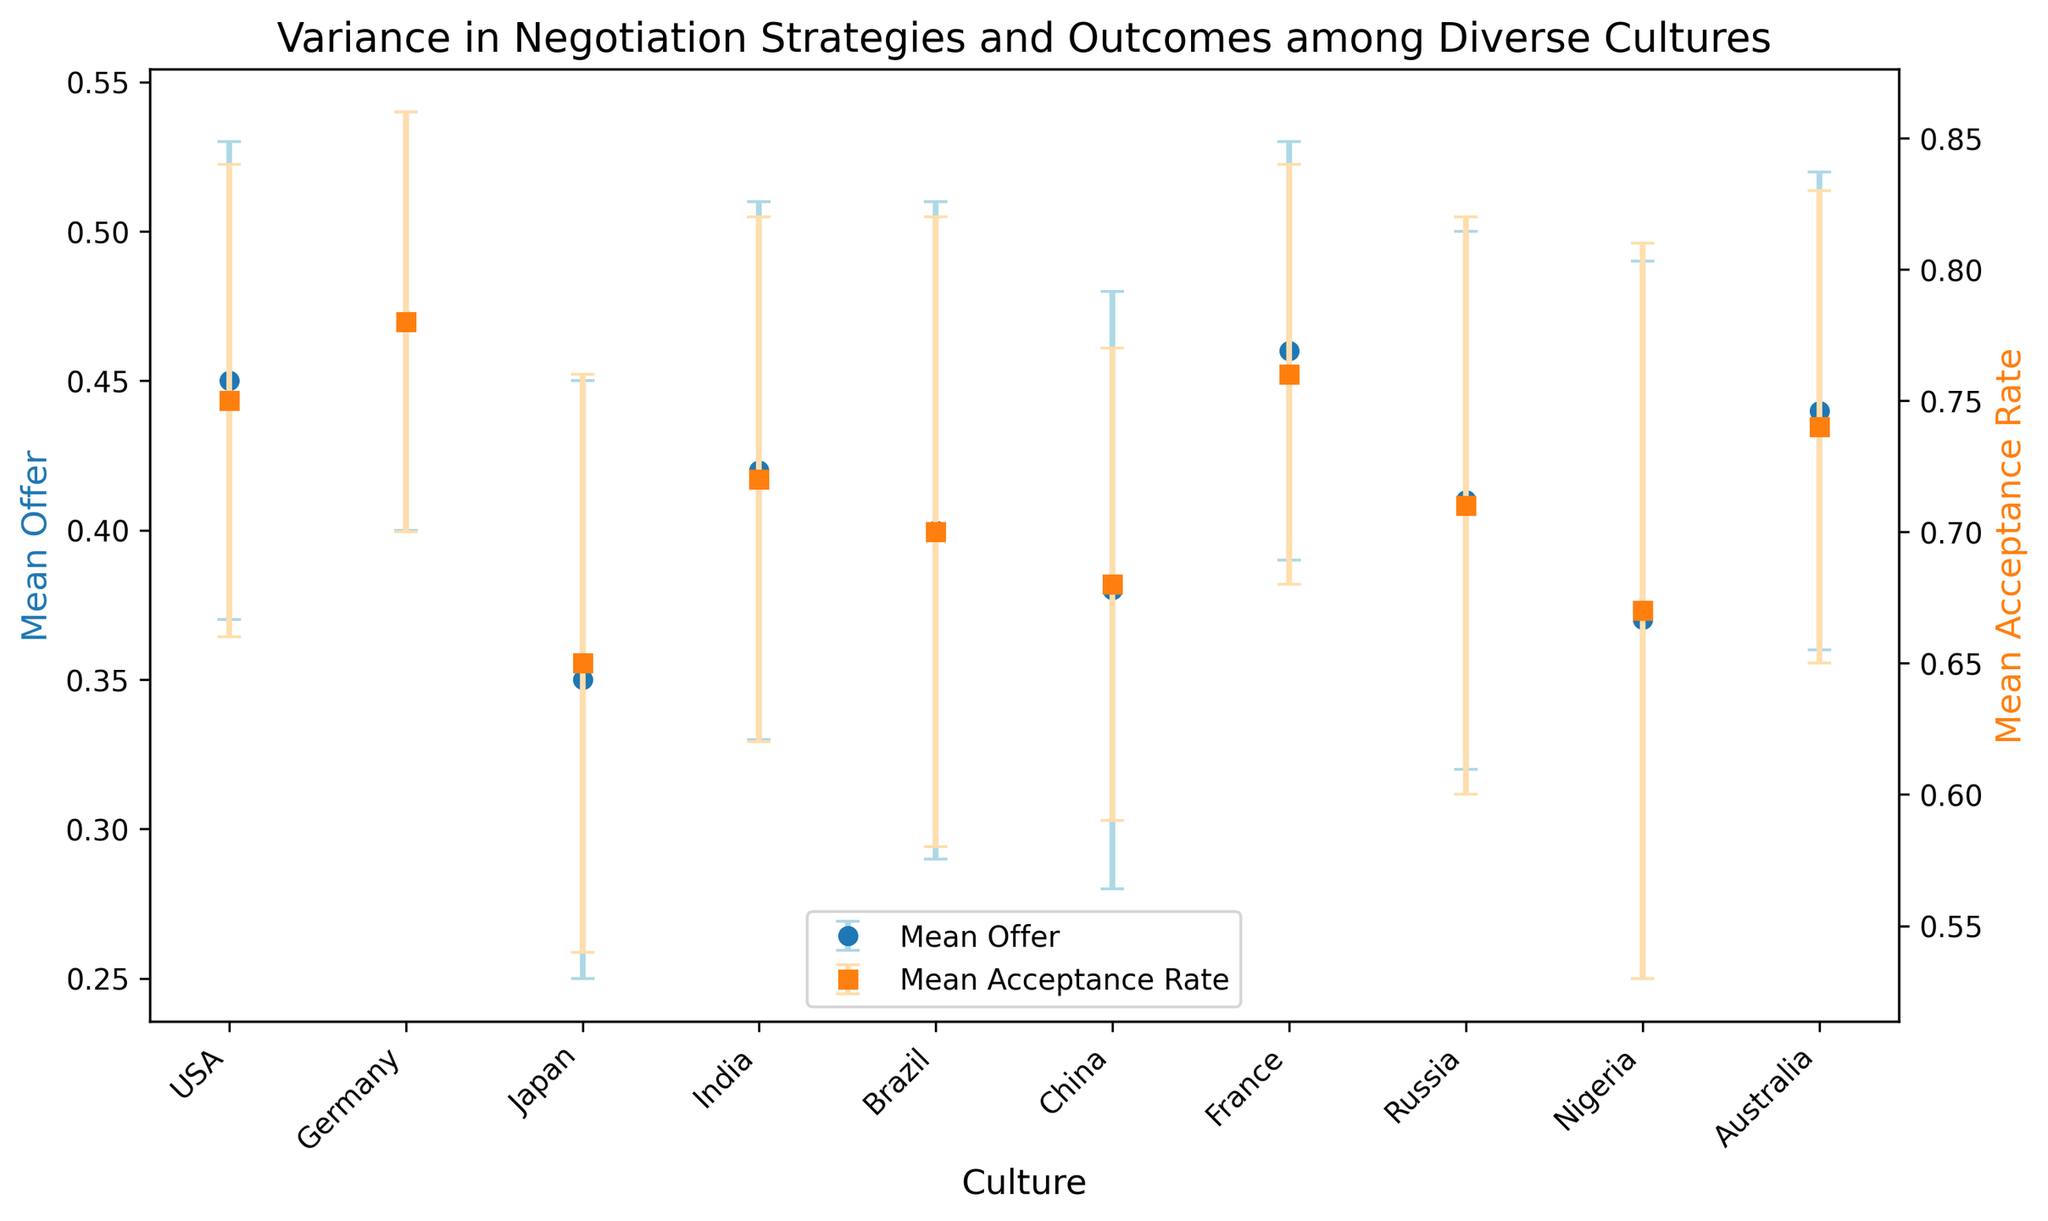Which culture has the highest mean offer? By examining the y-values of the blue dots (Mean Offer) on the left y-axis, Germany has the highest mean offer with a value of 0.47.
Answer: Germany Which culture has the lowest mean acceptance rate? By observing the y-values of the orange squares (Mean Acceptance Rate) on the right y-axis, Nigeria has the lowest mean acceptance rate with a value of 0.67.
Answer: Nigeria What is the difference in mean offer between USA and Japan? The mean offer for USA is 0.45 and for Japan, it is 0.35. The difference is 0.45 - 0.35 = 0.10.
Answer: 0.10 Which culture has the highest standard deviation in acceptance rate? By looking at the error bars for Mean Acceptance Rate (orange squares), Nigeria has the highest standard deviation in acceptance rate, which is 0.14.
Answer: Nigeria Do Brazil and India have the same mean offer? By comparing the y-values of the blue dots for Brazil and India on the left y-axis, Brazil has a mean offer of 0.40, and India has a mean offer of 0.42, so they do not have the same mean offer.
Answer: No What is the average mean acceptance rate for Germany and Brazil? The mean acceptance rate for Germany is 0.78 and for Brazil, it is 0.70. The average is (0.78 + 0.70) / 2 = 0.74.
Answer: 0.74 Which two cultures have mean offers within 0.01 of each other? By comparing the y-values of the blue dots, USA (0.45) and Australia (0.44) have mean offers within 0.01 of each other, as the difference is 0.01.
Answer: USA and Australia What is the sum of the standard deviations in mean offers for China and France? The standard deviation of the mean offer for China is 0.10 and for France, it is 0.07. The sum is 0.10 + 0.07 = 0.17.
Answer: 0.17 